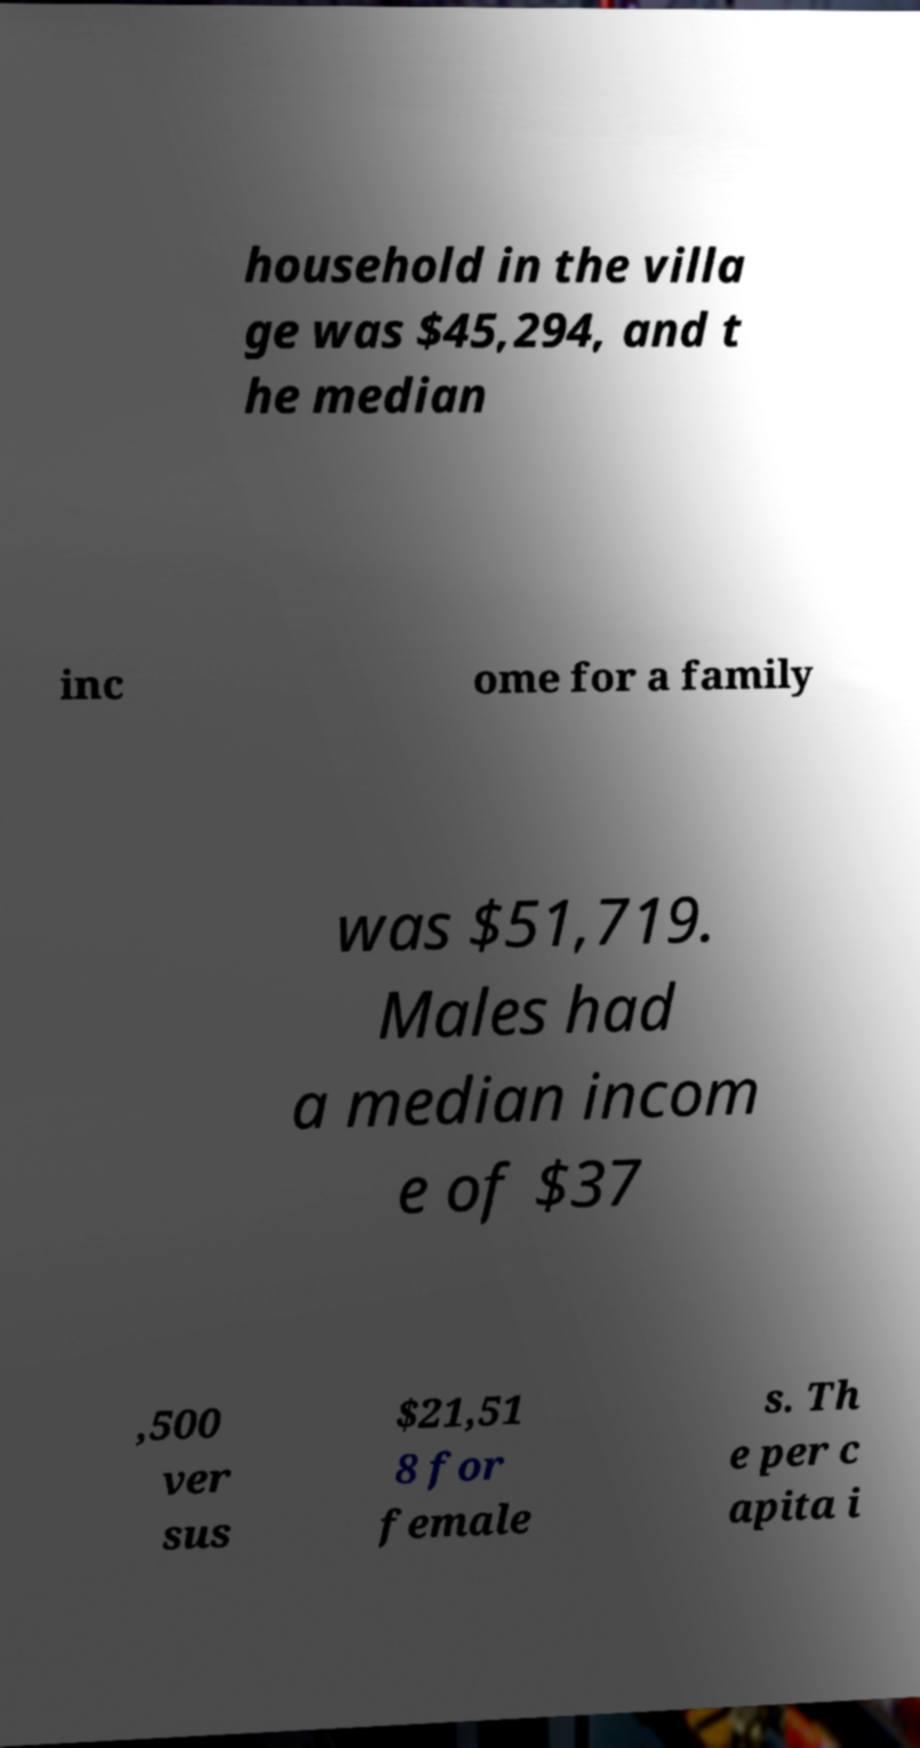There's text embedded in this image that I need extracted. Can you transcribe it verbatim? household in the villa ge was $45,294, and t he median inc ome for a family was $51,719. Males had a median incom e of $37 ,500 ver sus $21,51 8 for female s. Th e per c apita i 